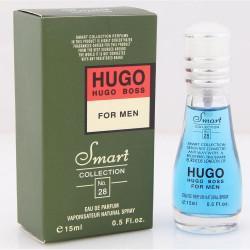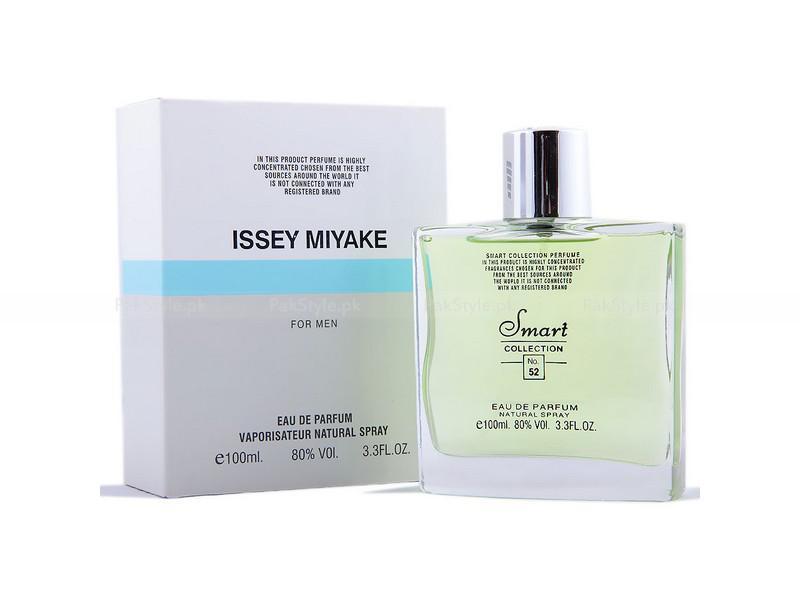The first image is the image on the left, the second image is the image on the right. For the images shown, is this caption "A square bottle of pale yellowish liquid stands to the right and slightly overlapping its box." true? Answer yes or no. Yes. The first image is the image on the left, the second image is the image on the right. Examine the images to the left and right. Is the description "There are more bottles of perfume with rounded edges than there are with sharp edges." accurate? Answer yes or no. No. 